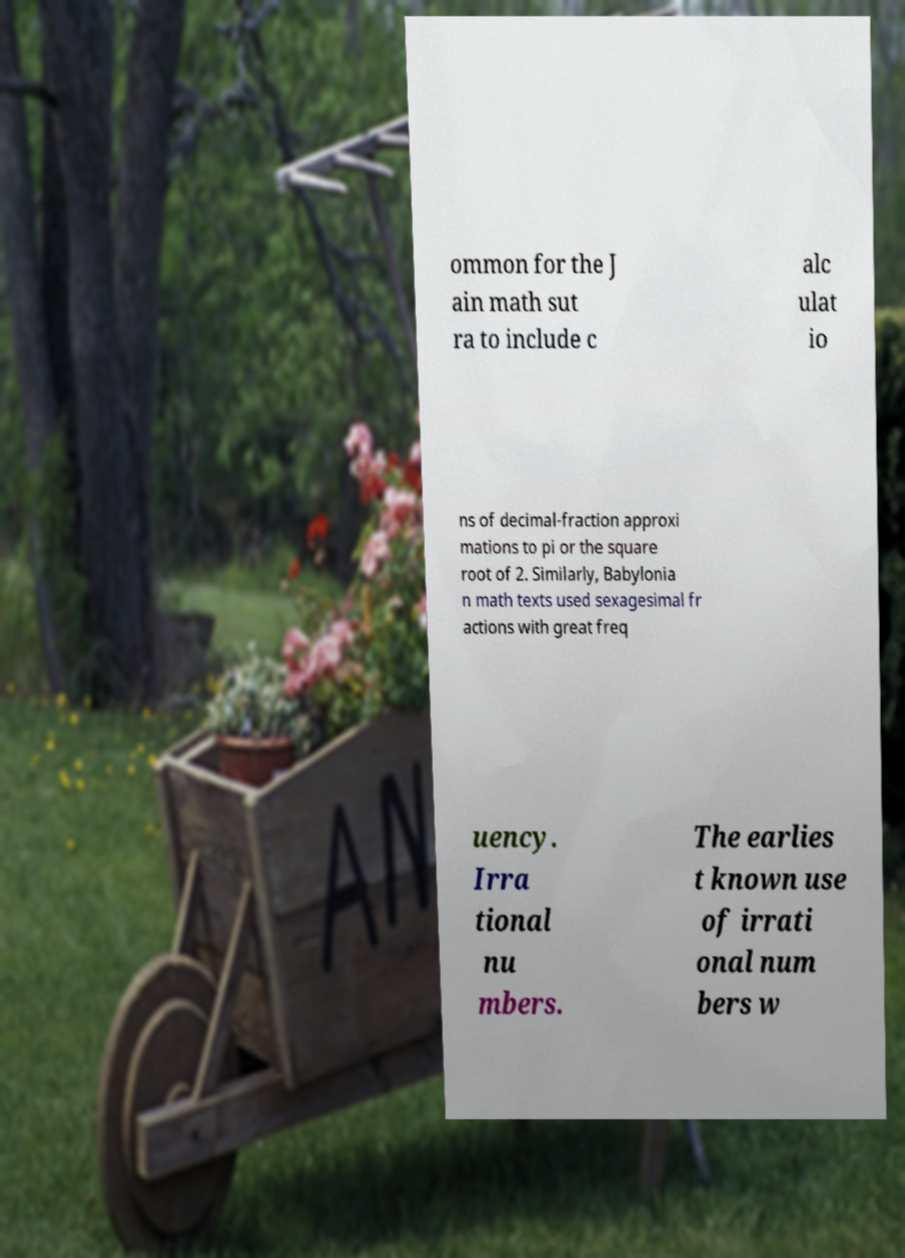Can you accurately transcribe the text from the provided image for me? ommon for the J ain math sut ra to include c alc ulat io ns of decimal-fraction approxi mations to pi or the square root of 2. Similarly, Babylonia n math texts used sexagesimal fr actions with great freq uency. Irra tional nu mbers. The earlies t known use of irrati onal num bers w 